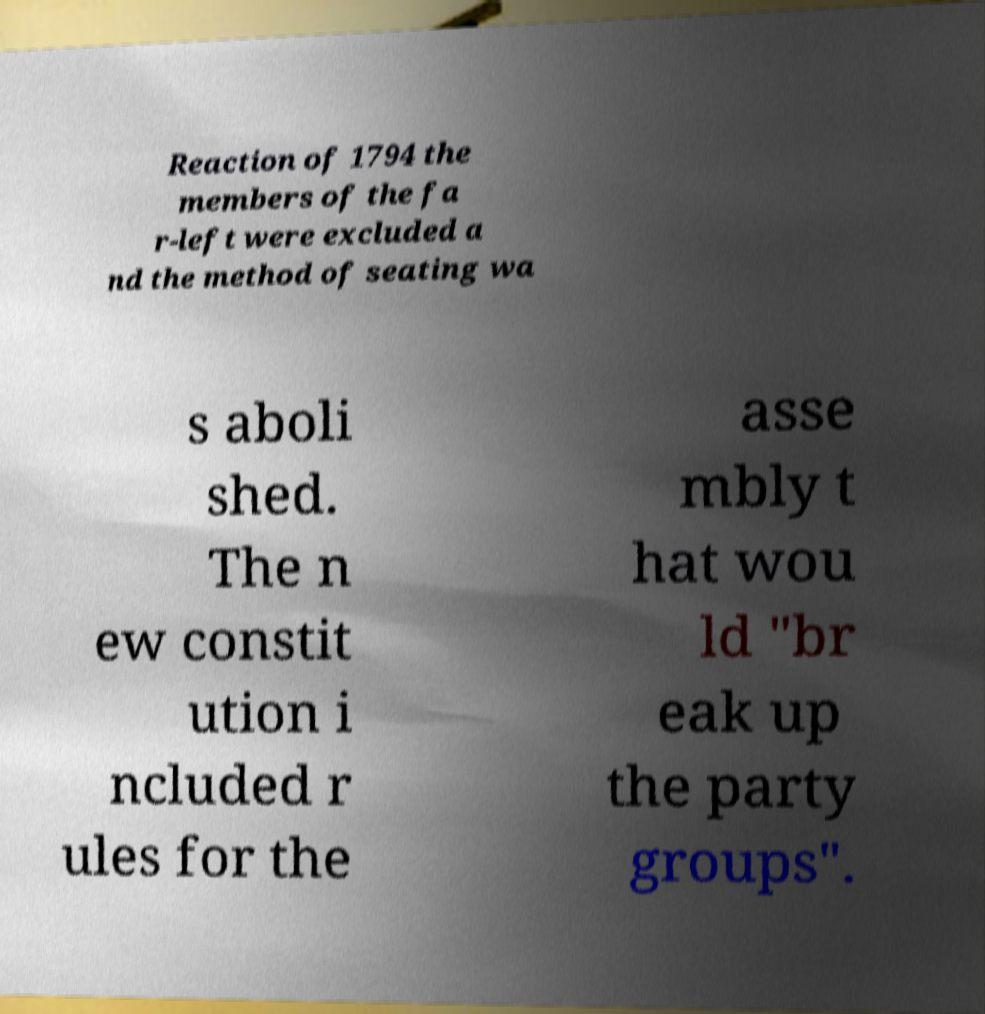Could you extract and type out the text from this image? Reaction of 1794 the members of the fa r-left were excluded a nd the method of seating wa s aboli shed. The n ew constit ution i ncluded r ules for the asse mbly t hat wou ld "br eak up the party groups". 